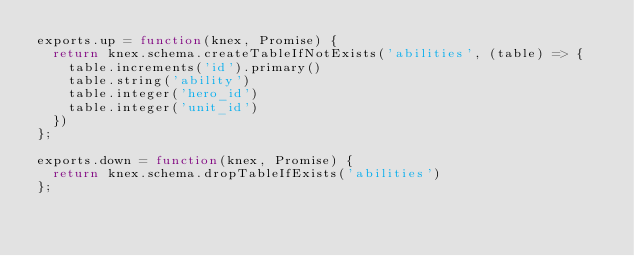<code> <loc_0><loc_0><loc_500><loc_500><_JavaScript_>exports.up = function(knex, Promise) {
  return knex.schema.createTableIfNotExists('abilities', (table) => {
    table.increments('id').primary()
    table.string('ability')
    table.integer('hero_id')
    table.integer('unit_id')
  })
};

exports.down = function(knex, Promise) {
  return knex.schema.dropTableIfExists('abilities')
};
</code> 